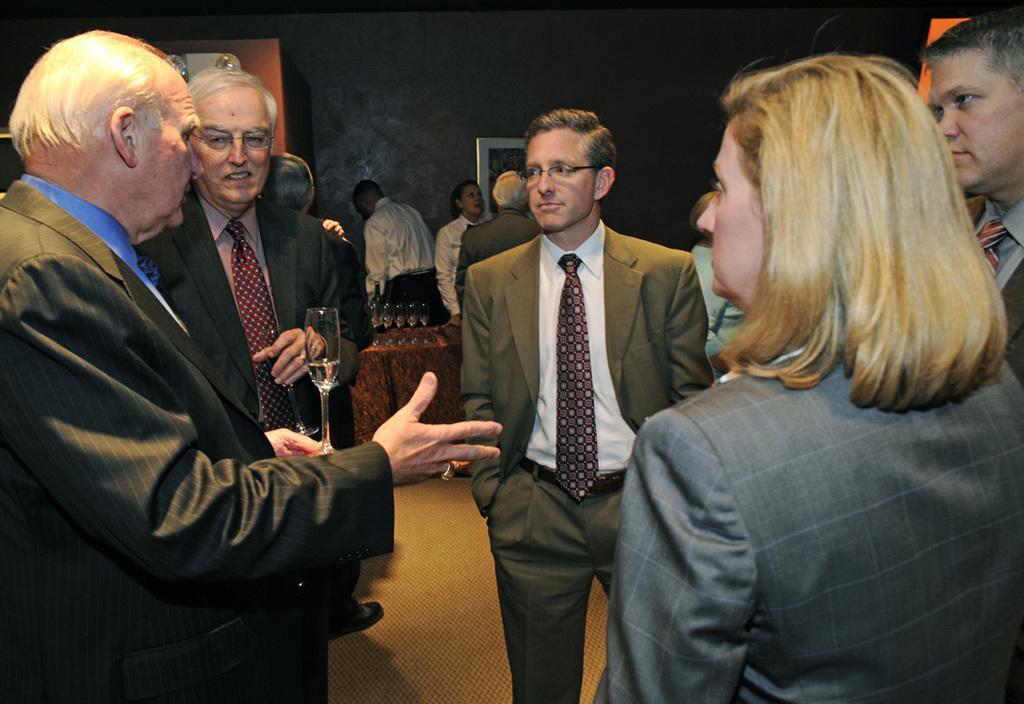Could you give a brief overview of what you see in this image? In this image we can see a few people, two of them are holding glasses, there are glasses on the table, there is a photo frame on the wall, also we can see a closet. 